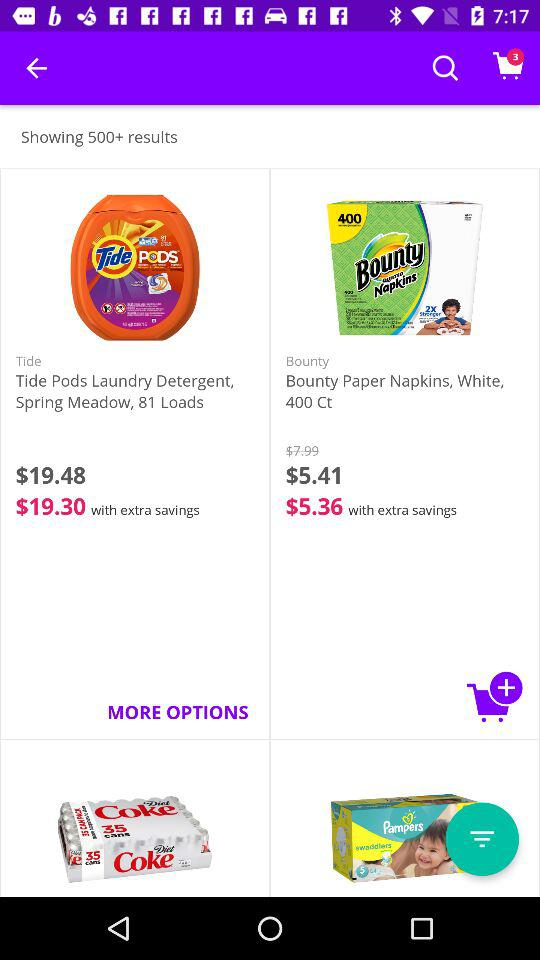What is the color of "Bounty Paper Napkins"? The color of "Bounty Paper Napkins" is white. 